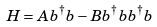<formula> <loc_0><loc_0><loc_500><loc_500>H = A b ^ { \dagger } b - B b ^ { \dagger } b b ^ { \dagger } b</formula> 